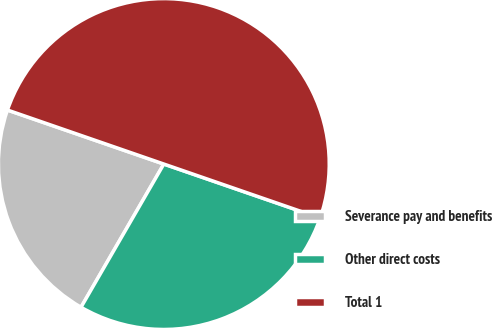Convert chart. <chart><loc_0><loc_0><loc_500><loc_500><pie_chart><fcel>Severance pay and benefits<fcel>Other direct costs<fcel>Total 1<nl><fcel>21.95%<fcel>28.05%<fcel>50.0%<nl></chart> 